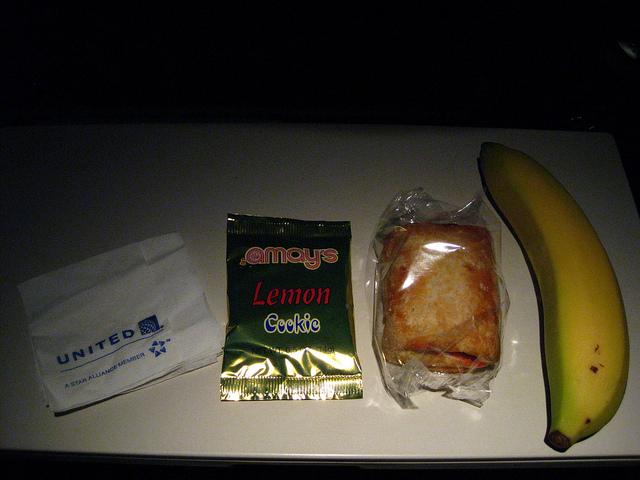Is there a lemon cookie in this picture?
Be succinct. Yes. What message has Dave written?
Answer briefly. None. What is on the surface under the banana?
Give a very brief answer. Table. What's drawn on the napkin?
Concise answer only. United. Will the bananas be dipped in toppings?
Give a very brief answer. No. What color is the banana?
Quick response, please. Yellow. What shape are the crackers in?
Short answer required. Square. Where is the napkin from?
Keep it brief. United. What color is the wrapper?
Give a very brief answer. Gold. How many bananas can be seen?
Answer briefly. 1. What is the banana sitting on?
Give a very brief answer. Table. 